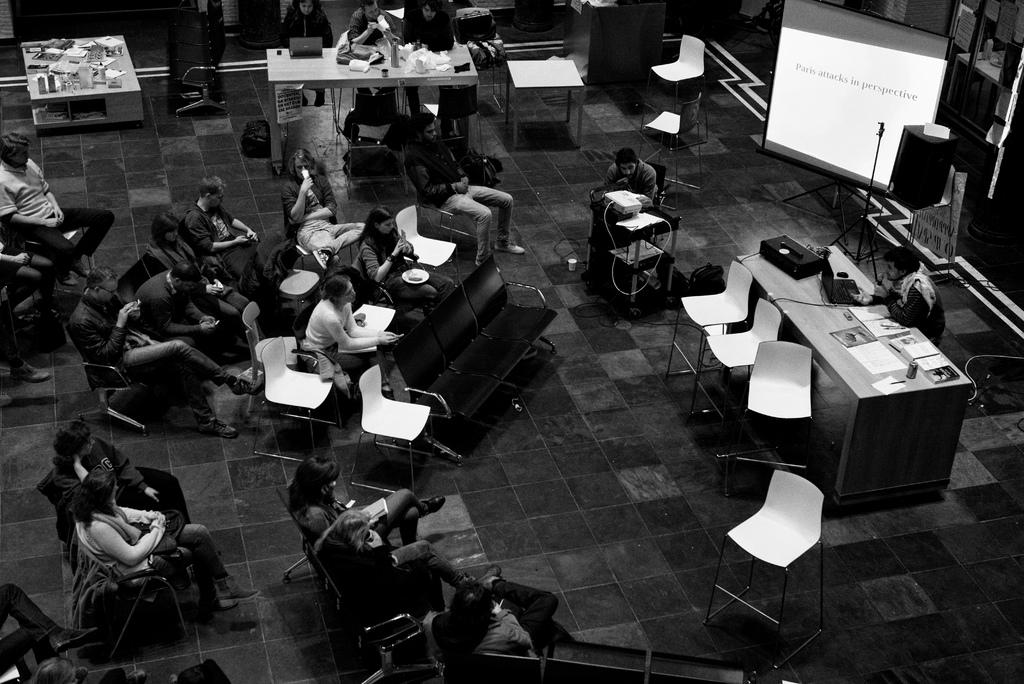What are the people in the image doing? The people in the image are sitting on chairs. What is the color scheme of the image? The image is in black and white color. What can be seen on the banner in the image? There is a screen on a banner in the image. What type of pickle is being used as a unit of measurement in the image? There is no pickle present in the image, and therefore no such measurement can be observed. 